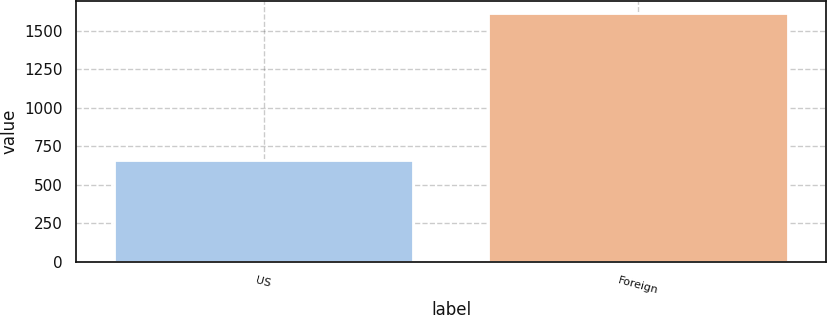Convert chart to OTSL. <chart><loc_0><loc_0><loc_500><loc_500><bar_chart><fcel>US<fcel>Foreign<nl><fcel>662<fcel>1612<nl></chart> 